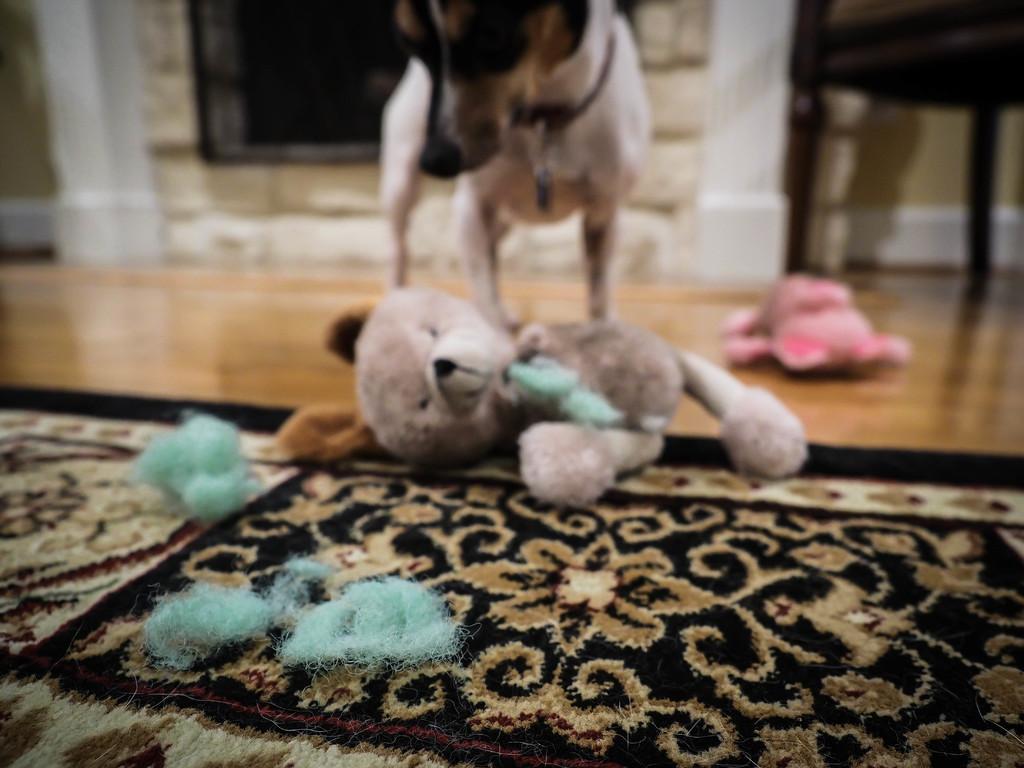Please provide a concise description of this image. In this image we can see one dog, one toy on the carpet, some object on the carpets, one toy on the floor, one object looks like a chair on the top right side of the image, one object attached to the wall in the background and the background is blurred. 